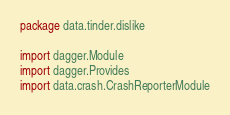Convert code to text. <code><loc_0><loc_0><loc_500><loc_500><_Kotlin_>package data.tinder.dislike

import dagger.Module
import dagger.Provides
import data.crash.CrashReporterModule</code> 